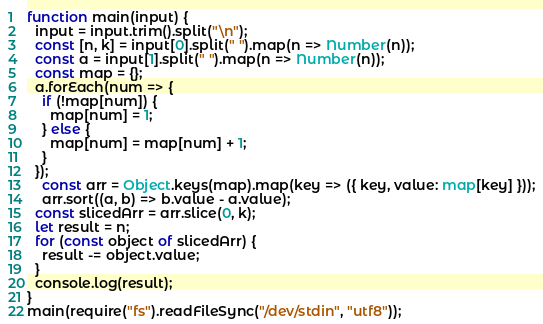<code> <loc_0><loc_0><loc_500><loc_500><_TypeScript_>function main(input) {
  input = input.trim().split("\n");
  const [n, k] = input[0].split(" ").map(n => Number(n));
  const a = input[1].split(" ").map(n => Number(n));
  const map = {};
  a.forEach(num => {
    if (!map[num]) {
      map[num] = 1;
    } else {
      map[num] = map[num] + 1;
    }
  });
    const arr = Object.keys(map).map(key => ({ key, value: map[key] }));
    arr.sort((a, b) => b.value - a.value);
  const slicedArr = arr.slice(0, k);
  let result = n;
  for (const object of slicedArr) {
  	result -= object.value;
  }
  console.log(result);
}
main(require("fs").readFileSync("/dev/stdin", "utf8"));</code> 